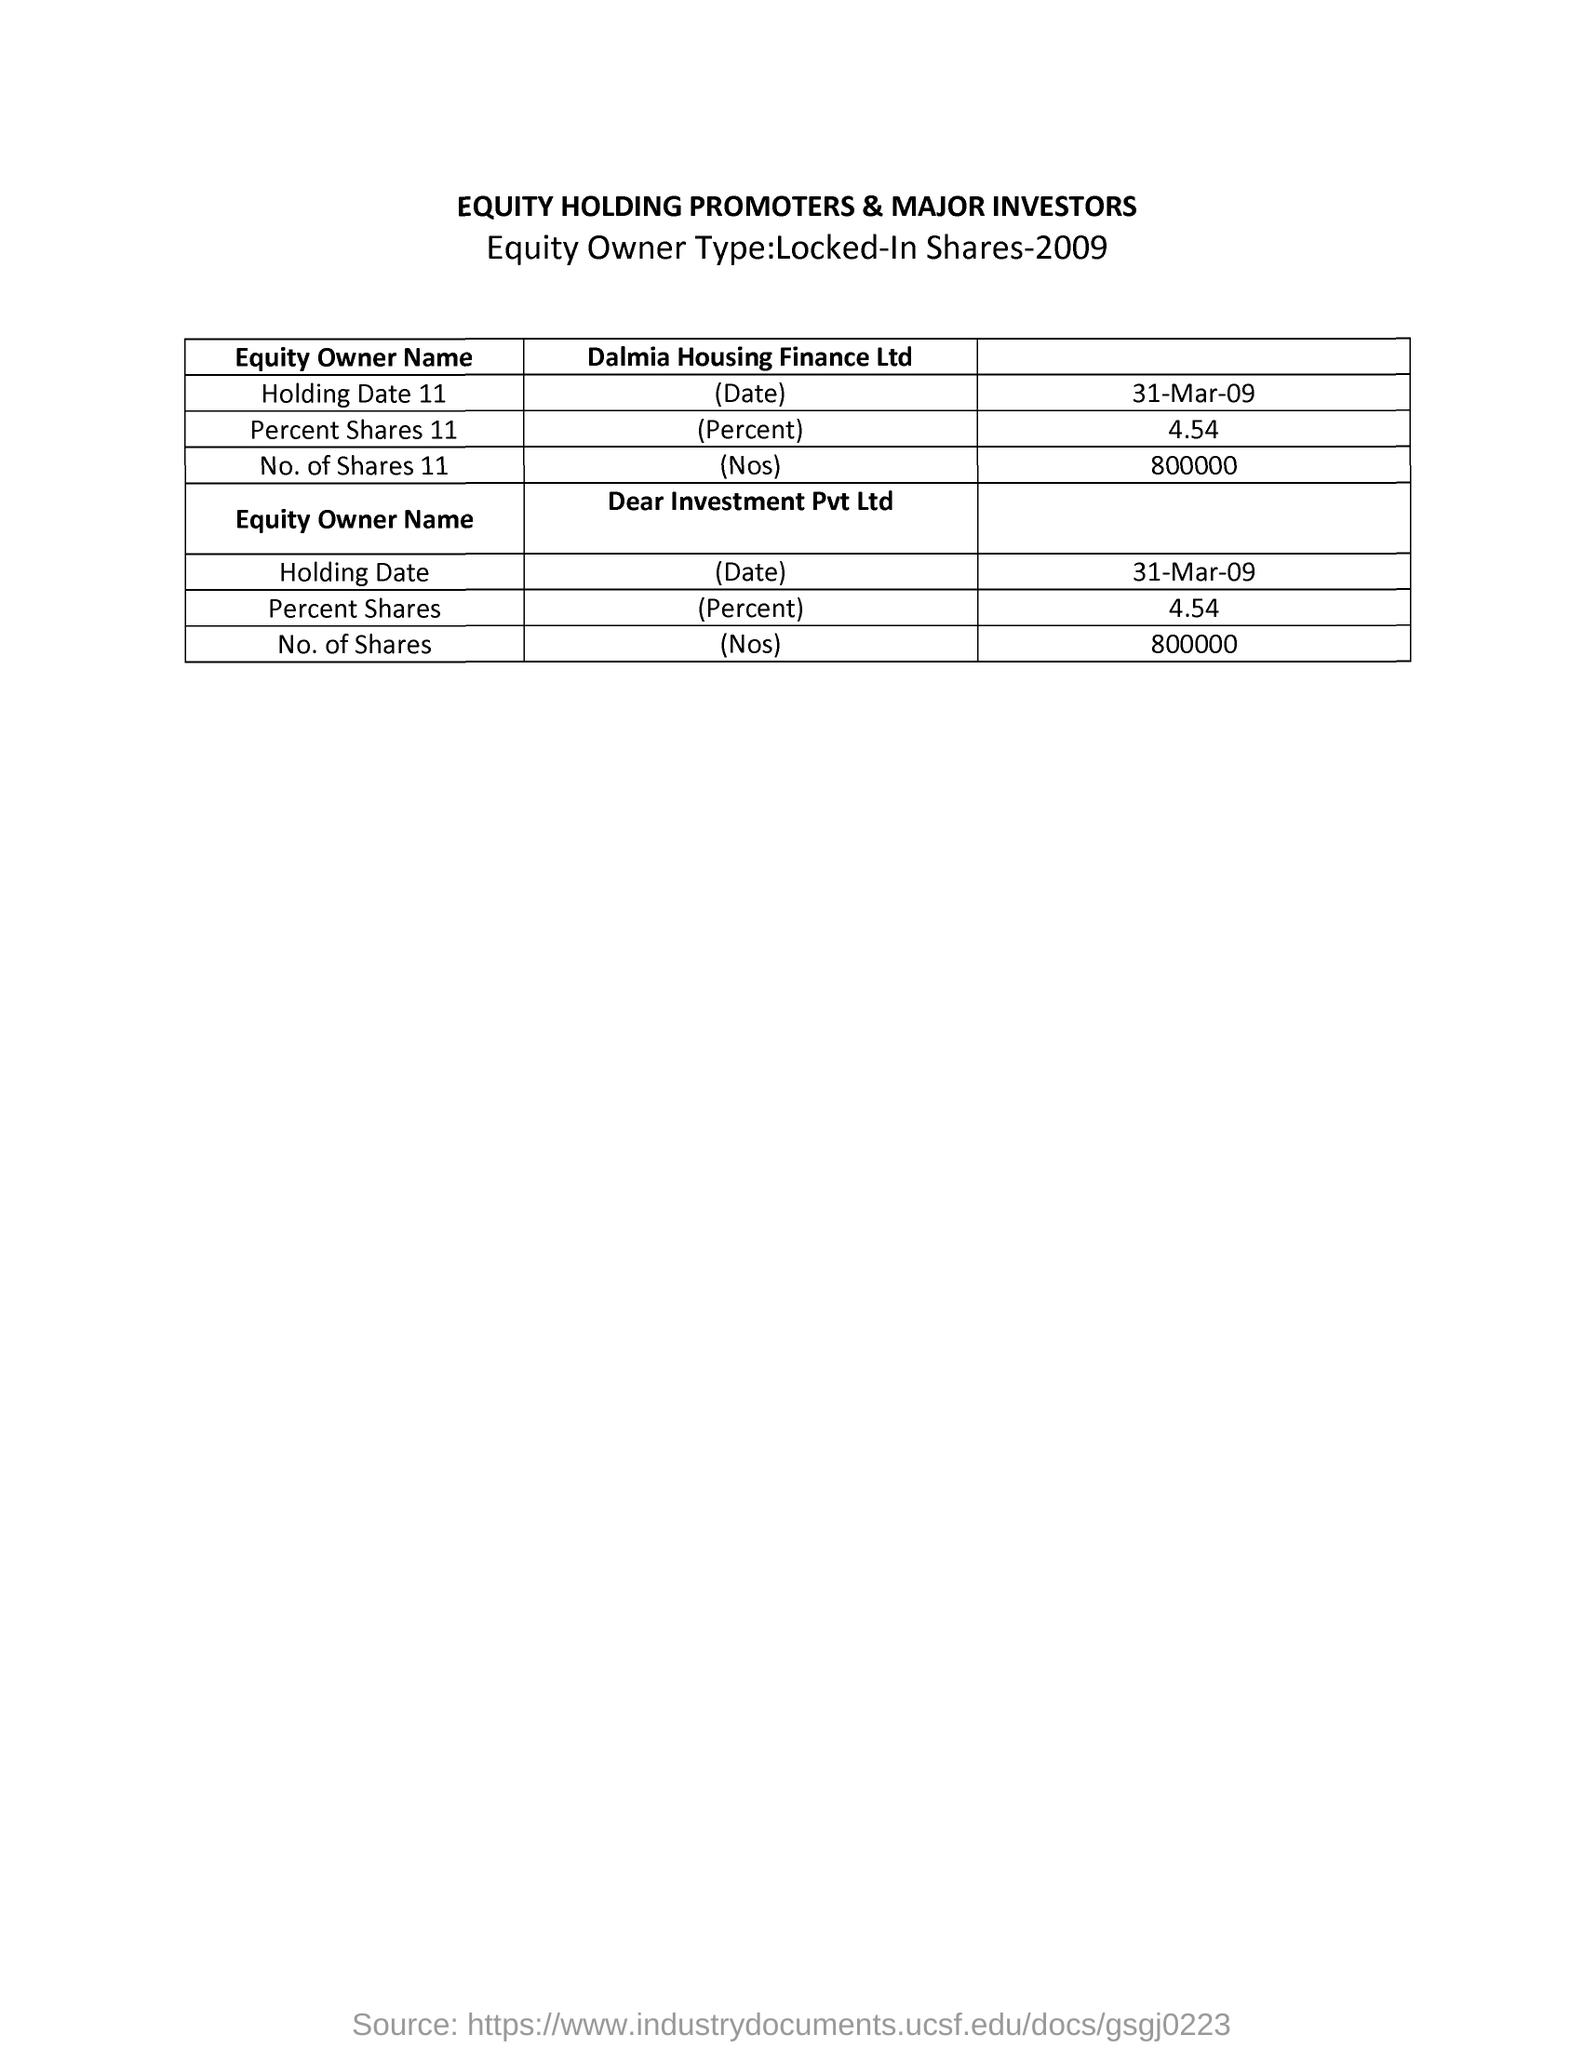List a handful of essential elements in this visual. The given document is titled "Equity Holding Promoters & Major Investors. The total number of shares in Dear Investment Pvt. Ltd. is 800,000. On March 31, 2009, Dalmia Housing Finance Ltd. held a certain value, which is referred to as "holding date 11. Dalmia Housing Finance Ltd.'s share of 11% is 4.54%. The year in which the equity owner type was locked in shares was 2009. 